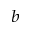<formula> <loc_0><loc_0><loc_500><loc_500>^ { b }</formula> 